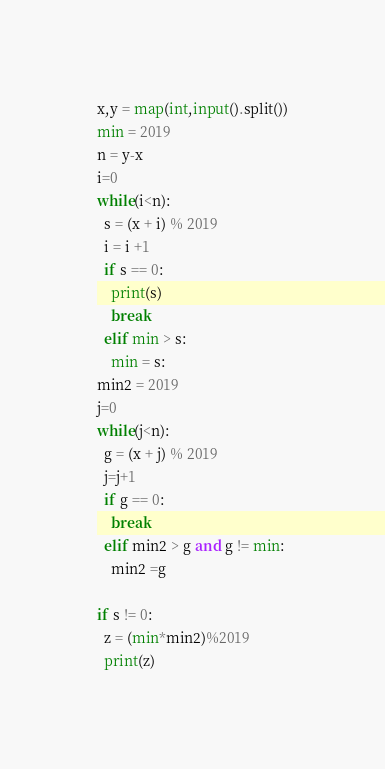<code> <loc_0><loc_0><loc_500><loc_500><_Python_>x,y = map(int,input().split())
min = 2019
n = y-x
i=0
while(i<n):
  s = (x + i) % 2019
  i = i +1
  if s == 0:
    print(s)
    break
  elif min > s:
    min = s:
min2 = 2019
j=0
while(j<n):
  g = (x + j) % 2019
  j=j+1
  if g == 0:
    break
  elif min2 > g and g != min:
    min2 =g

if s != 0:
  z = (min*min2)%2019
  print(z)
</code> 